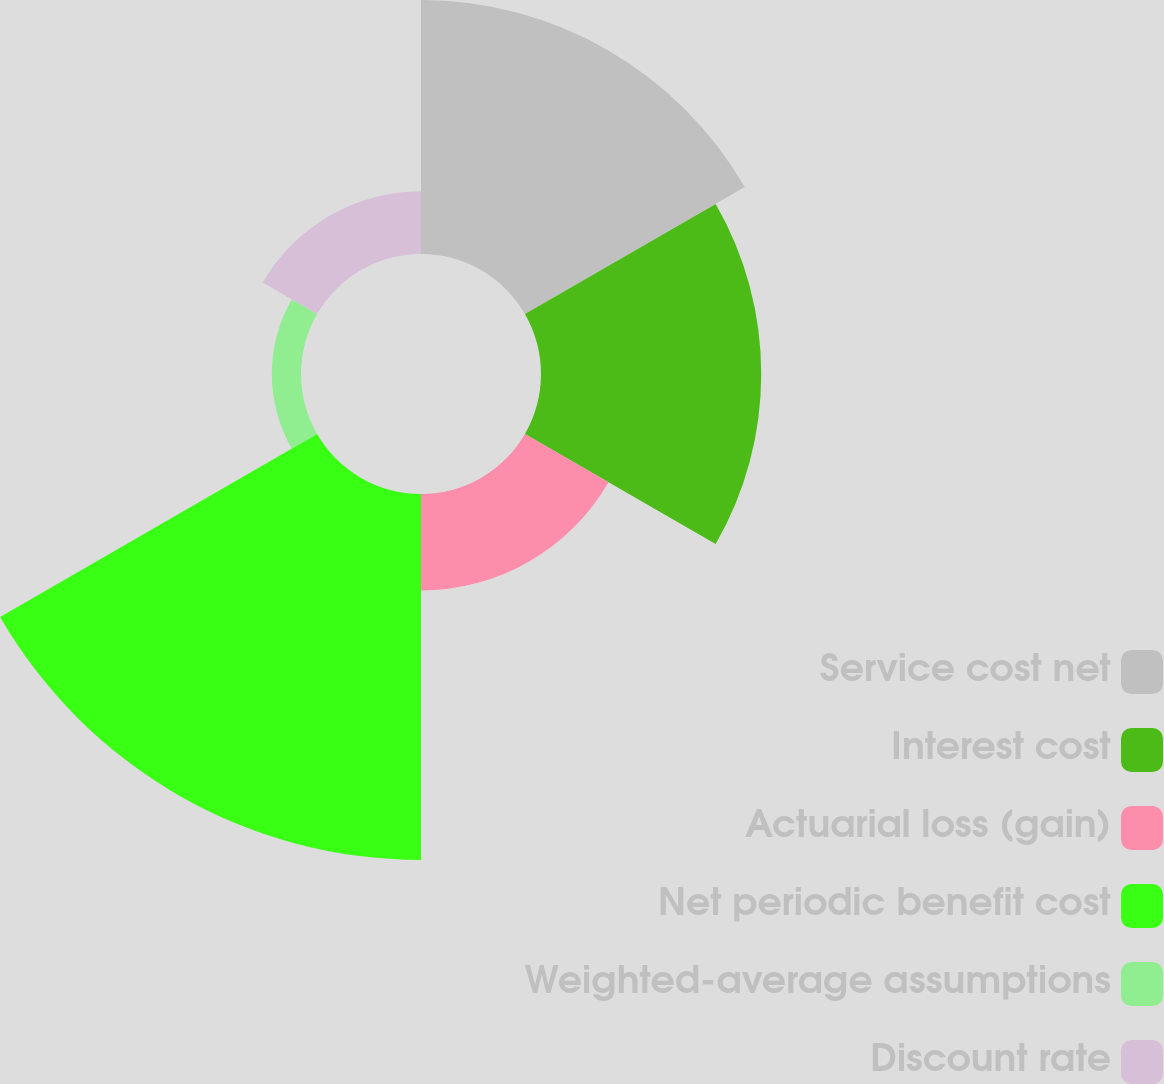Convert chart. <chart><loc_0><loc_0><loc_500><loc_500><pie_chart><fcel>Service cost net<fcel>Interest cost<fcel>Actuarial loss (gain)<fcel>Net periodic benefit cost<fcel>Weighted-average assumptions<fcel>Discount rate<nl><fcel>24.68%<fcel>21.41%<fcel>9.38%<fcel>35.58%<fcel>2.84%<fcel>6.11%<nl></chart> 